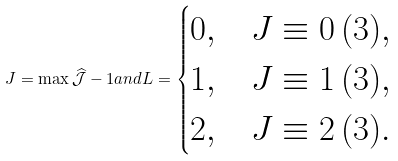<formula> <loc_0><loc_0><loc_500><loc_500>J = \max \widehat { \mathcal { J } } - 1 a n d L = \begin{cases} 0 , & J \equiv 0 \, ( 3 ) , \\ 1 , & J \equiv 1 \, ( 3 ) , \\ 2 , & J \equiv 2 \, ( 3 ) . \end{cases}</formula> 